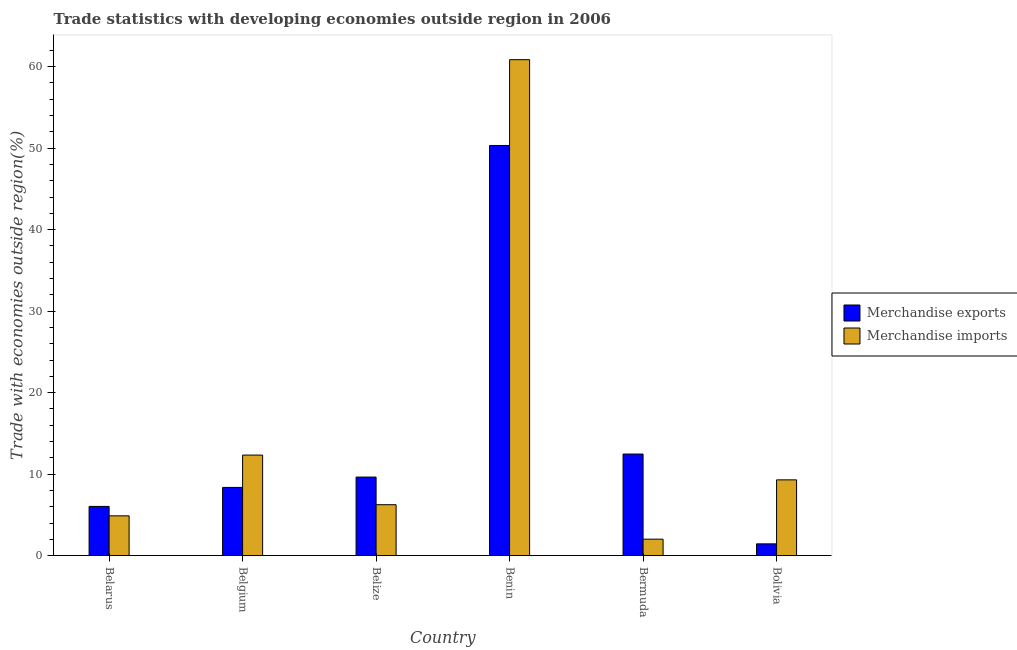How many groups of bars are there?
Your response must be concise. 6. Are the number of bars per tick equal to the number of legend labels?
Your answer should be compact. Yes. Are the number of bars on each tick of the X-axis equal?
Ensure brevity in your answer.  Yes. What is the label of the 1st group of bars from the left?
Give a very brief answer. Belarus. What is the merchandise exports in Bermuda?
Your response must be concise. 12.47. Across all countries, what is the maximum merchandise exports?
Your answer should be compact. 50.33. Across all countries, what is the minimum merchandise imports?
Your answer should be very brief. 2.02. In which country was the merchandise imports maximum?
Your answer should be very brief. Benin. In which country was the merchandise imports minimum?
Your answer should be compact. Bermuda. What is the total merchandise exports in the graph?
Keep it short and to the point. 88.3. What is the difference between the merchandise imports in Benin and that in Bolivia?
Provide a succinct answer. 51.55. What is the difference between the merchandise imports in Benin and the merchandise exports in Belarus?
Make the answer very short. 54.81. What is the average merchandise exports per country?
Give a very brief answer. 14.72. What is the difference between the merchandise imports and merchandise exports in Benin?
Give a very brief answer. 10.53. What is the ratio of the merchandise exports in Bermuda to that in Bolivia?
Your answer should be compact. 8.61. What is the difference between the highest and the second highest merchandise exports?
Offer a terse response. 37.86. What is the difference between the highest and the lowest merchandise exports?
Your answer should be compact. 48.88. How many countries are there in the graph?
Give a very brief answer. 6. What is the difference between two consecutive major ticks on the Y-axis?
Make the answer very short. 10. Does the graph contain any zero values?
Your response must be concise. No. Where does the legend appear in the graph?
Keep it short and to the point. Center right. How are the legend labels stacked?
Provide a short and direct response. Vertical. What is the title of the graph?
Your response must be concise. Trade statistics with developing economies outside region in 2006. What is the label or title of the Y-axis?
Offer a very short reply. Trade with economies outside region(%). What is the Trade with economies outside region(%) in Merchandise exports in Belarus?
Give a very brief answer. 6.04. What is the Trade with economies outside region(%) in Merchandise imports in Belarus?
Offer a very short reply. 4.88. What is the Trade with economies outside region(%) in Merchandise exports in Belgium?
Provide a succinct answer. 8.37. What is the Trade with economies outside region(%) of Merchandise imports in Belgium?
Ensure brevity in your answer.  12.34. What is the Trade with economies outside region(%) in Merchandise exports in Belize?
Provide a short and direct response. 9.64. What is the Trade with economies outside region(%) in Merchandise imports in Belize?
Make the answer very short. 6.25. What is the Trade with economies outside region(%) in Merchandise exports in Benin?
Provide a short and direct response. 50.33. What is the Trade with economies outside region(%) of Merchandise imports in Benin?
Your response must be concise. 60.85. What is the Trade with economies outside region(%) of Merchandise exports in Bermuda?
Your response must be concise. 12.47. What is the Trade with economies outside region(%) in Merchandise imports in Bermuda?
Provide a short and direct response. 2.02. What is the Trade with economies outside region(%) of Merchandise exports in Bolivia?
Ensure brevity in your answer.  1.45. What is the Trade with economies outside region(%) in Merchandise imports in Bolivia?
Provide a succinct answer. 9.3. Across all countries, what is the maximum Trade with economies outside region(%) in Merchandise exports?
Offer a very short reply. 50.33. Across all countries, what is the maximum Trade with economies outside region(%) in Merchandise imports?
Your answer should be compact. 60.85. Across all countries, what is the minimum Trade with economies outside region(%) in Merchandise exports?
Give a very brief answer. 1.45. Across all countries, what is the minimum Trade with economies outside region(%) in Merchandise imports?
Your answer should be compact. 2.02. What is the total Trade with economies outside region(%) in Merchandise exports in the graph?
Give a very brief answer. 88.3. What is the total Trade with economies outside region(%) of Merchandise imports in the graph?
Keep it short and to the point. 95.65. What is the difference between the Trade with economies outside region(%) in Merchandise exports in Belarus and that in Belgium?
Make the answer very short. -2.33. What is the difference between the Trade with economies outside region(%) in Merchandise imports in Belarus and that in Belgium?
Your response must be concise. -7.45. What is the difference between the Trade with economies outside region(%) in Merchandise exports in Belarus and that in Belize?
Provide a short and direct response. -3.6. What is the difference between the Trade with economies outside region(%) in Merchandise imports in Belarus and that in Belize?
Provide a succinct answer. -1.37. What is the difference between the Trade with economies outside region(%) in Merchandise exports in Belarus and that in Benin?
Your answer should be compact. -44.28. What is the difference between the Trade with economies outside region(%) of Merchandise imports in Belarus and that in Benin?
Keep it short and to the point. -55.97. What is the difference between the Trade with economies outside region(%) of Merchandise exports in Belarus and that in Bermuda?
Give a very brief answer. -6.43. What is the difference between the Trade with economies outside region(%) in Merchandise imports in Belarus and that in Bermuda?
Keep it short and to the point. 2.86. What is the difference between the Trade with economies outside region(%) of Merchandise exports in Belarus and that in Bolivia?
Your answer should be compact. 4.59. What is the difference between the Trade with economies outside region(%) in Merchandise imports in Belarus and that in Bolivia?
Your response must be concise. -4.42. What is the difference between the Trade with economies outside region(%) in Merchandise exports in Belgium and that in Belize?
Your answer should be compact. -1.27. What is the difference between the Trade with economies outside region(%) in Merchandise imports in Belgium and that in Belize?
Make the answer very short. 6.09. What is the difference between the Trade with economies outside region(%) of Merchandise exports in Belgium and that in Benin?
Offer a very short reply. -41.95. What is the difference between the Trade with economies outside region(%) in Merchandise imports in Belgium and that in Benin?
Provide a short and direct response. -48.51. What is the difference between the Trade with economies outside region(%) in Merchandise exports in Belgium and that in Bermuda?
Give a very brief answer. -4.1. What is the difference between the Trade with economies outside region(%) in Merchandise imports in Belgium and that in Bermuda?
Make the answer very short. 10.32. What is the difference between the Trade with economies outside region(%) of Merchandise exports in Belgium and that in Bolivia?
Provide a short and direct response. 6.92. What is the difference between the Trade with economies outside region(%) of Merchandise imports in Belgium and that in Bolivia?
Give a very brief answer. 3.04. What is the difference between the Trade with economies outside region(%) of Merchandise exports in Belize and that in Benin?
Keep it short and to the point. -40.68. What is the difference between the Trade with economies outside region(%) of Merchandise imports in Belize and that in Benin?
Your answer should be very brief. -54.6. What is the difference between the Trade with economies outside region(%) of Merchandise exports in Belize and that in Bermuda?
Your answer should be compact. -2.83. What is the difference between the Trade with economies outside region(%) in Merchandise imports in Belize and that in Bermuda?
Your answer should be compact. 4.23. What is the difference between the Trade with economies outside region(%) of Merchandise exports in Belize and that in Bolivia?
Your answer should be very brief. 8.19. What is the difference between the Trade with economies outside region(%) of Merchandise imports in Belize and that in Bolivia?
Provide a short and direct response. -3.05. What is the difference between the Trade with economies outside region(%) in Merchandise exports in Benin and that in Bermuda?
Your response must be concise. 37.86. What is the difference between the Trade with economies outside region(%) of Merchandise imports in Benin and that in Bermuda?
Offer a terse response. 58.83. What is the difference between the Trade with economies outside region(%) of Merchandise exports in Benin and that in Bolivia?
Offer a very short reply. 48.88. What is the difference between the Trade with economies outside region(%) of Merchandise imports in Benin and that in Bolivia?
Give a very brief answer. 51.55. What is the difference between the Trade with economies outside region(%) of Merchandise exports in Bermuda and that in Bolivia?
Your response must be concise. 11.02. What is the difference between the Trade with economies outside region(%) in Merchandise imports in Bermuda and that in Bolivia?
Offer a very short reply. -7.28. What is the difference between the Trade with economies outside region(%) in Merchandise exports in Belarus and the Trade with economies outside region(%) in Merchandise imports in Belgium?
Make the answer very short. -6.3. What is the difference between the Trade with economies outside region(%) in Merchandise exports in Belarus and the Trade with economies outside region(%) in Merchandise imports in Belize?
Keep it short and to the point. -0.21. What is the difference between the Trade with economies outside region(%) in Merchandise exports in Belarus and the Trade with economies outside region(%) in Merchandise imports in Benin?
Provide a succinct answer. -54.81. What is the difference between the Trade with economies outside region(%) in Merchandise exports in Belarus and the Trade with economies outside region(%) in Merchandise imports in Bermuda?
Your answer should be very brief. 4.02. What is the difference between the Trade with economies outside region(%) of Merchandise exports in Belarus and the Trade with economies outside region(%) of Merchandise imports in Bolivia?
Your answer should be compact. -3.26. What is the difference between the Trade with economies outside region(%) in Merchandise exports in Belgium and the Trade with economies outside region(%) in Merchandise imports in Belize?
Your answer should be very brief. 2.12. What is the difference between the Trade with economies outside region(%) of Merchandise exports in Belgium and the Trade with economies outside region(%) of Merchandise imports in Benin?
Keep it short and to the point. -52.48. What is the difference between the Trade with economies outside region(%) of Merchandise exports in Belgium and the Trade with economies outside region(%) of Merchandise imports in Bermuda?
Make the answer very short. 6.35. What is the difference between the Trade with economies outside region(%) of Merchandise exports in Belgium and the Trade with economies outside region(%) of Merchandise imports in Bolivia?
Your answer should be compact. -0.93. What is the difference between the Trade with economies outside region(%) in Merchandise exports in Belize and the Trade with economies outside region(%) in Merchandise imports in Benin?
Your answer should be compact. -51.21. What is the difference between the Trade with economies outside region(%) of Merchandise exports in Belize and the Trade with economies outside region(%) of Merchandise imports in Bermuda?
Keep it short and to the point. 7.62. What is the difference between the Trade with economies outside region(%) in Merchandise exports in Belize and the Trade with economies outside region(%) in Merchandise imports in Bolivia?
Your answer should be compact. 0.34. What is the difference between the Trade with economies outside region(%) in Merchandise exports in Benin and the Trade with economies outside region(%) in Merchandise imports in Bermuda?
Offer a terse response. 48.3. What is the difference between the Trade with economies outside region(%) in Merchandise exports in Benin and the Trade with economies outside region(%) in Merchandise imports in Bolivia?
Make the answer very short. 41.02. What is the difference between the Trade with economies outside region(%) in Merchandise exports in Bermuda and the Trade with economies outside region(%) in Merchandise imports in Bolivia?
Offer a very short reply. 3.17. What is the average Trade with economies outside region(%) of Merchandise exports per country?
Offer a very short reply. 14.72. What is the average Trade with economies outside region(%) of Merchandise imports per country?
Provide a succinct answer. 15.94. What is the difference between the Trade with economies outside region(%) of Merchandise exports and Trade with economies outside region(%) of Merchandise imports in Belarus?
Keep it short and to the point. 1.16. What is the difference between the Trade with economies outside region(%) of Merchandise exports and Trade with economies outside region(%) of Merchandise imports in Belgium?
Offer a terse response. -3.97. What is the difference between the Trade with economies outside region(%) in Merchandise exports and Trade with economies outside region(%) in Merchandise imports in Belize?
Make the answer very short. 3.39. What is the difference between the Trade with economies outside region(%) in Merchandise exports and Trade with economies outside region(%) in Merchandise imports in Benin?
Offer a very short reply. -10.53. What is the difference between the Trade with economies outside region(%) in Merchandise exports and Trade with economies outside region(%) in Merchandise imports in Bermuda?
Provide a succinct answer. 10.45. What is the difference between the Trade with economies outside region(%) of Merchandise exports and Trade with economies outside region(%) of Merchandise imports in Bolivia?
Your answer should be compact. -7.85. What is the ratio of the Trade with economies outside region(%) of Merchandise exports in Belarus to that in Belgium?
Your answer should be compact. 0.72. What is the ratio of the Trade with economies outside region(%) in Merchandise imports in Belarus to that in Belgium?
Give a very brief answer. 0.4. What is the ratio of the Trade with economies outside region(%) of Merchandise exports in Belarus to that in Belize?
Make the answer very short. 0.63. What is the ratio of the Trade with economies outside region(%) in Merchandise imports in Belarus to that in Belize?
Your answer should be very brief. 0.78. What is the ratio of the Trade with economies outside region(%) in Merchandise exports in Belarus to that in Benin?
Your answer should be very brief. 0.12. What is the ratio of the Trade with economies outside region(%) of Merchandise imports in Belarus to that in Benin?
Your answer should be compact. 0.08. What is the ratio of the Trade with economies outside region(%) of Merchandise exports in Belarus to that in Bermuda?
Your answer should be compact. 0.48. What is the ratio of the Trade with economies outside region(%) of Merchandise imports in Belarus to that in Bermuda?
Offer a very short reply. 2.41. What is the ratio of the Trade with economies outside region(%) in Merchandise exports in Belarus to that in Bolivia?
Keep it short and to the point. 4.17. What is the ratio of the Trade with economies outside region(%) in Merchandise imports in Belarus to that in Bolivia?
Give a very brief answer. 0.53. What is the ratio of the Trade with economies outside region(%) of Merchandise exports in Belgium to that in Belize?
Make the answer very short. 0.87. What is the ratio of the Trade with economies outside region(%) of Merchandise imports in Belgium to that in Belize?
Your answer should be very brief. 1.97. What is the ratio of the Trade with economies outside region(%) in Merchandise exports in Belgium to that in Benin?
Offer a very short reply. 0.17. What is the ratio of the Trade with economies outside region(%) in Merchandise imports in Belgium to that in Benin?
Offer a very short reply. 0.2. What is the ratio of the Trade with economies outside region(%) of Merchandise exports in Belgium to that in Bermuda?
Give a very brief answer. 0.67. What is the ratio of the Trade with economies outside region(%) of Merchandise imports in Belgium to that in Bermuda?
Your response must be concise. 6.1. What is the ratio of the Trade with economies outside region(%) of Merchandise exports in Belgium to that in Bolivia?
Your answer should be very brief. 5.78. What is the ratio of the Trade with economies outside region(%) of Merchandise imports in Belgium to that in Bolivia?
Provide a succinct answer. 1.33. What is the ratio of the Trade with economies outside region(%) in Merchandise exports in Belize to that in Benin?
Give a very brief answer. 0.19. What is the ratio of the Trade with economies outside region(%) in Merchandise imports in Belize to that in Benin?
Your answer should be compact. 0.1. What is the ratio of the Trade with economies outside region(%) of Merchandise exports in Belize to that in Bermuda?
Give a very brief answer. 0.77. What is the ratio of the Trade with economies outside region(%) of Merchandise imports in Belize to that in Bermuda?
Offer a very short reply. 3.09. What is the ratio of the Trade with economies outside region(%) of Merchandise exports in Belize to that in Bolivia?
Provide a short and direct response. 6.66. What is the ratio of the Trade with economies outside region(%) of Merchandise imports in Belize to that in Bolivia?
Offer a terse response. 0.67. What is the ratio of the Trade with economies outside region(%) of Merchandise exports in Benin to that in Bermuda?
Ensure brevity in your answer.  4.04. What is the ratio of the Trade with economies outside region(%) in Merchandise imports in Benin to that in Bermuda?
Make the answer very short. 30.09. What is the ratio of the Trade with economies outside region(%) of Merchandise exports in Benin to that in Bolivia?
Make the answer very short. 34.77. What is the ratio of the Trade with economies outside region(%) of Merchandise imports in Benin to that in Bolivia?
Ensure brevity in your answer.  6.54. What is the ratio of the Trade with economies outside region(%) of Merchandise exports in Bermuda to that in Bolivia?
Offer a very short reply. 8.61. What is the ratio of the Trade with economies outside region(%) in Merchandise imports in Bermuda to that in Bolivia?
Make the answer very short. 0.22. What is the difference between the highest and the second highest Trade with economies outside region(%) in Merchandise exports?
Your answer should be compact. 37.86. What is the difference between the highest and the second highest Trade with economies outside region(%) of Merchandise imports?
Keep it short and to the point. 48.51. What is the difference between the highest and the lowest Trade with economies outside region(%) in Merchandise exports?
Provide a succinct answer. 48.88. What is the difference between the highest and the lowest Trade with economies outside region(%) of Merchandise imports?
Offer a terse response. 58.83. 